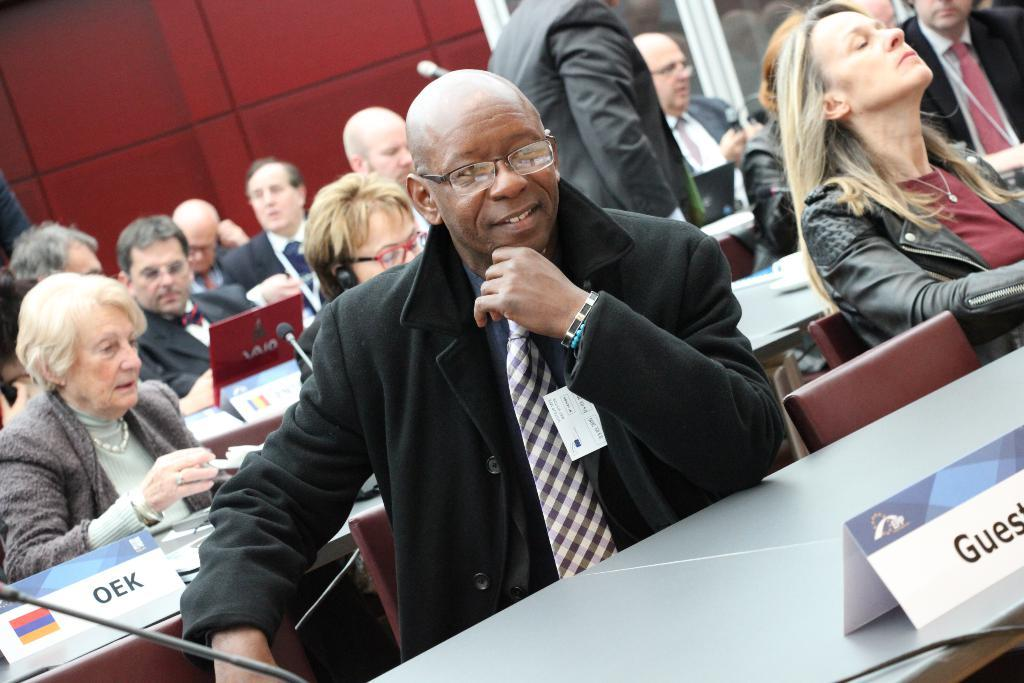What are the people in the image doing? The people in the image are sitting on chairs. What objects are placed in front of the chairs? Tables are placed in front of the chairs. What can be found on the tables? Name boards, microphones (mics), and laptops are visible on the tables. What type of wilderness can be seen in the background of the image? There is no wilderness visible in the image; it is focused on the people, chairs, and tables. 